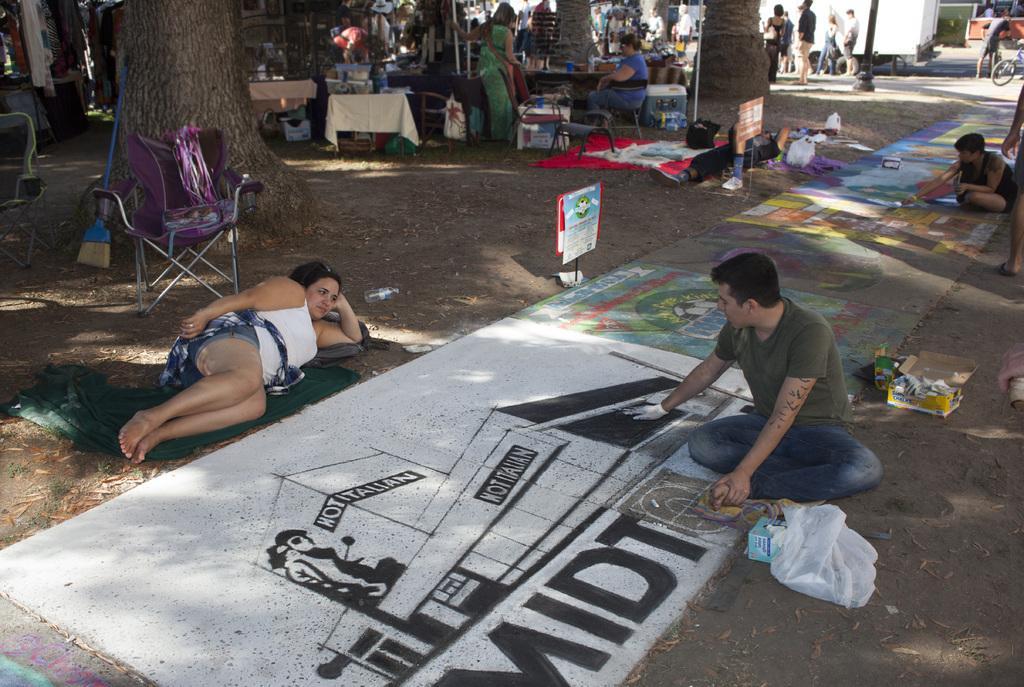Could you give a brief overview of what you see in this image? In this picture I can see few people standing and few are seated on the ground and a woman seated on the chair and I can see few tables and few articles on the tables and I can see few people painting on the ground and I can see a bicycle and a chair on the side and a woman laying on the ground and I can see couple of boards with some text and I can see couple of boxes and a carry bag on the ground. 